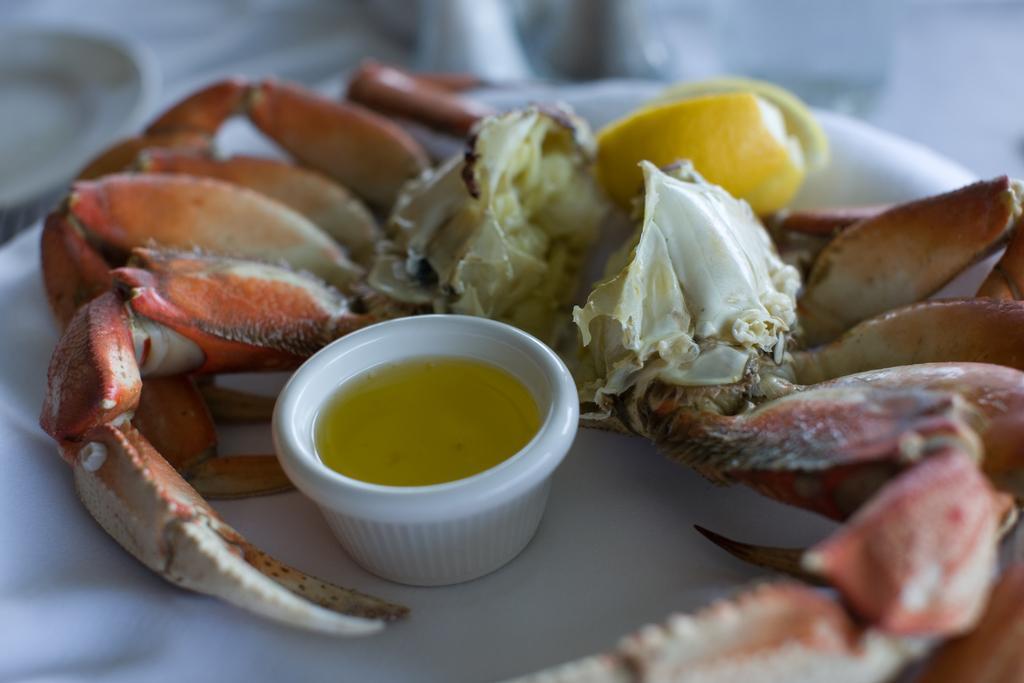Could you give a brief overview of what you see in this image? In this picture, we can see a table, on that table there are some food items and a cup with some liquid in it. On the right side corner, we can also see another plate. 